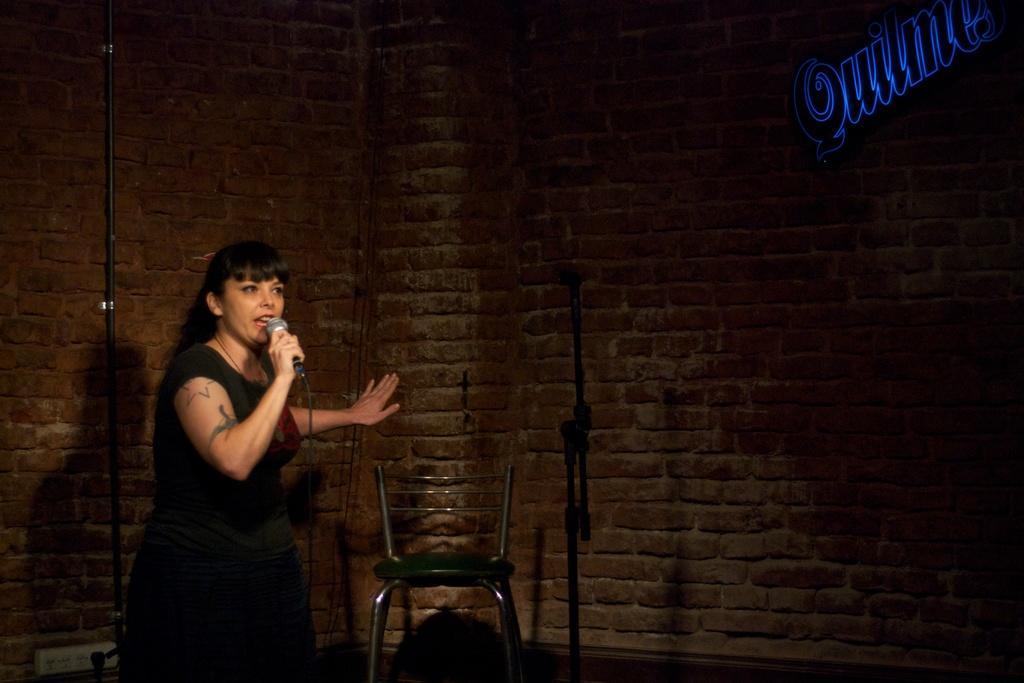How would you summarize this image in a sentence or two? In this picture there is a lady on the left side of the image, by holding a mic in her hand and there is a chair in the center of the image. 